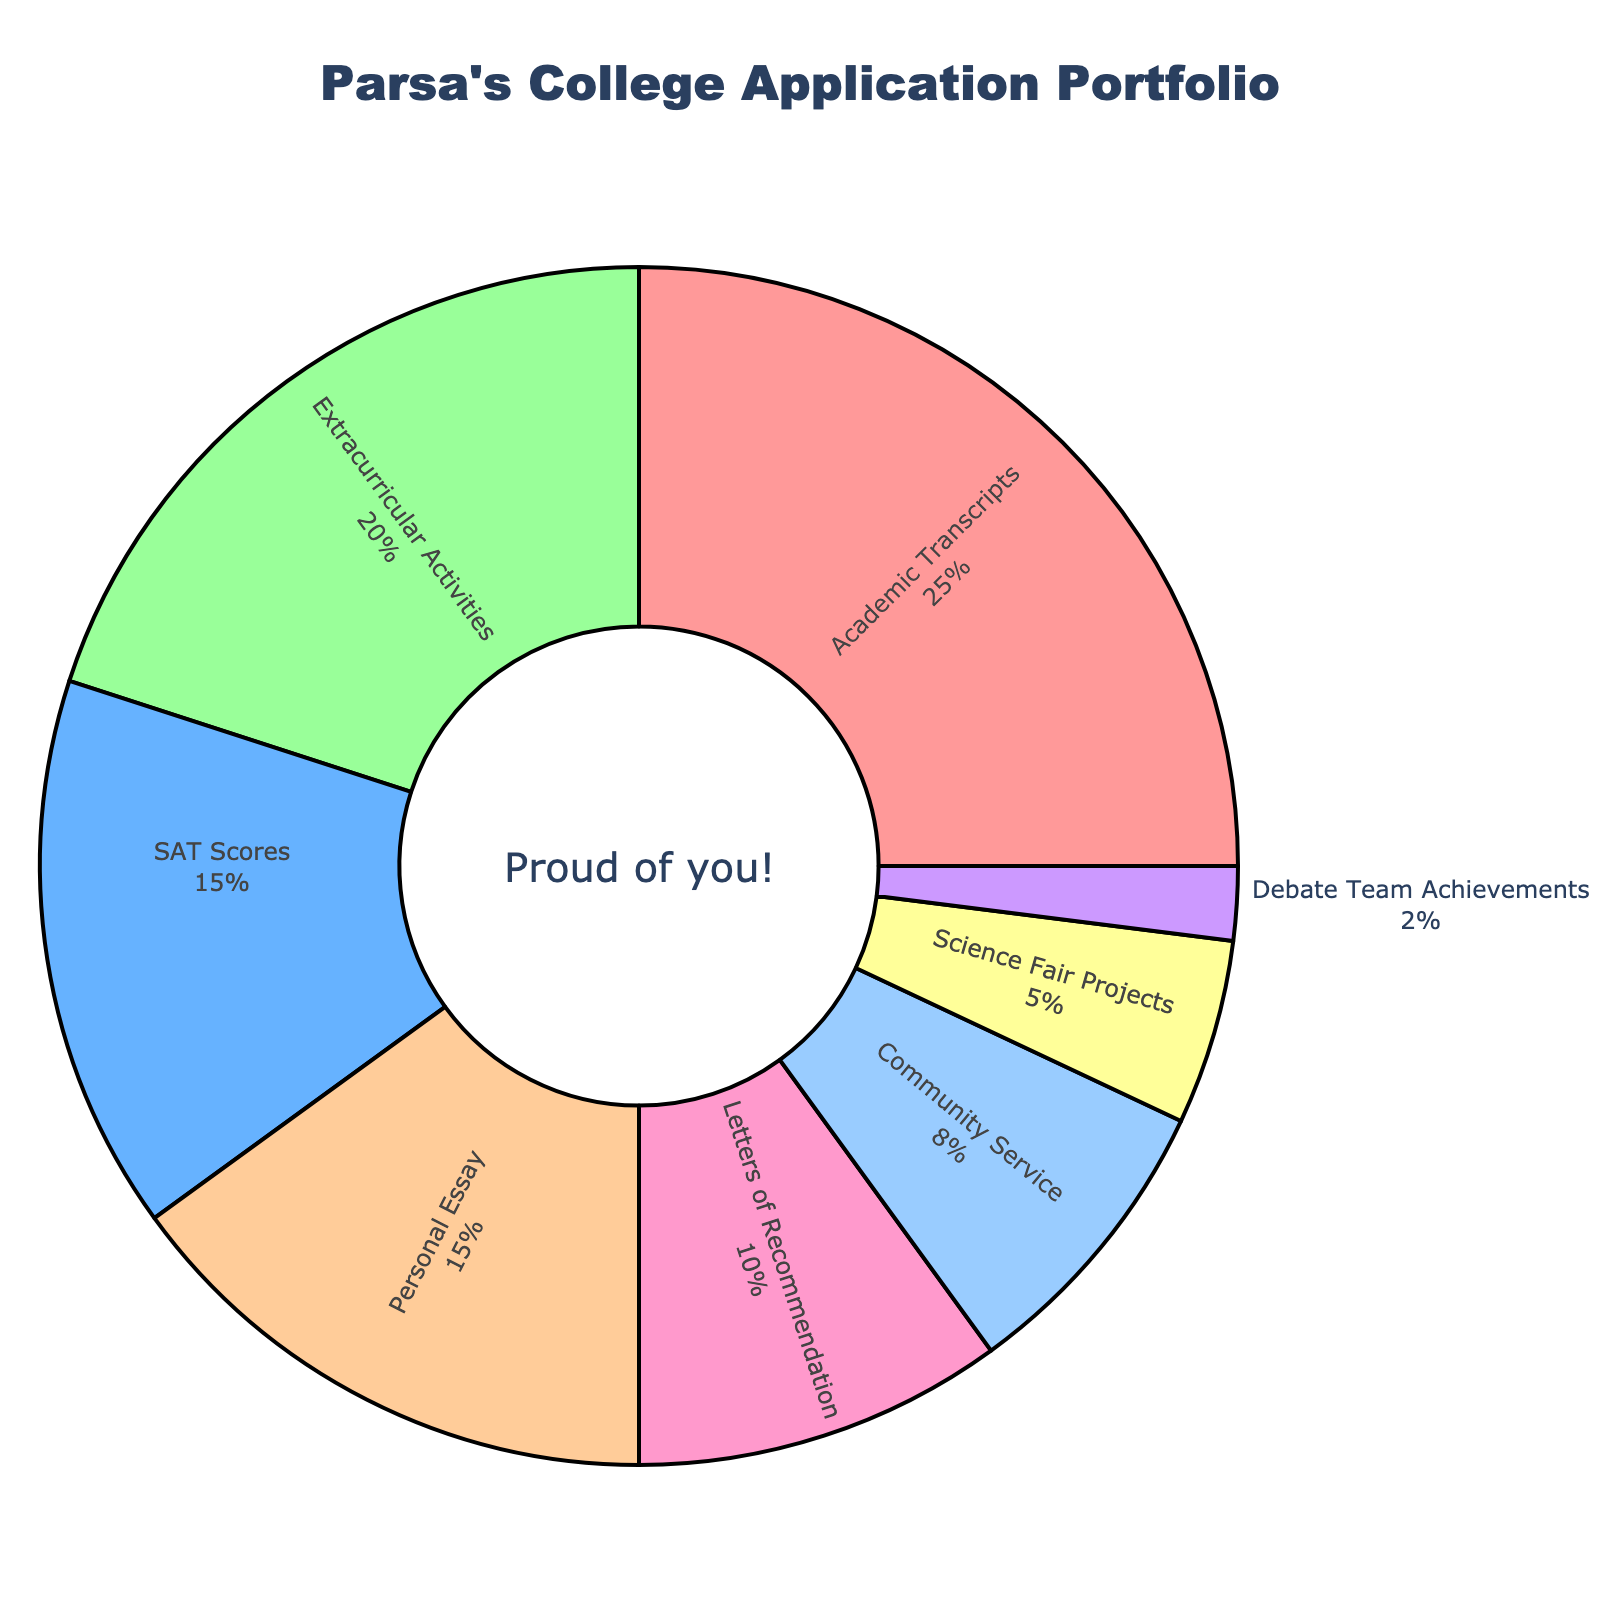What's the largest component of Parsa's college application portfolio? The largest component can be identified by looking for the segment with the biggest percentage. The "Academic Transcripts" segment is the largest with 25%.
Answer: Academic Transcripts What is the combined percentage of "Personal Essay" and "SAT Scores"? The percentages for "Personal Essay" and "SAT Scores" are 15% each. Adding these together gives 15 + 15 = 30%.
Answer: 30% Which component has the smallest percentage, and what is that percentage? The smallest segment has to be the one with the smallest value. The "Debate Team Achievements" is the smallest with 2%.
Answer: Debate Team Achievements, 2% By how much does the "Extracurricular Activities" percentage exceed the "Community Service" percentage? Subtract the "Community Service" percentage (8%) from the "Extracurricular Activities" percentage (20%) to find the difference: 20 - 8 = 12%.
Answer: 12% What components collectively make up more than 50% of the application portfolio? By summing the largest components until the total exceeds 50%, we find that "Academic Transcripts" (25%), "Extracurricular Activities" (20%), and "SAT Scores" (15%) together total 60%, which is more than 50%.
Answer: Academic Transcripts, Extracurricular Activities, SAT Scores What is the percentage difference between the "Letters of Recommendation" and "Science Fair Projects" components? Subtract the percentage of "Science Fair Projects" (5%) from "Letters of Recommendation" (10%): 10 - 5 = 5%.
Answer: 5% If the "Extracurricular Activities" and "Community Service" percentages were combined into one component, what would be the new percentage? Adding the "Extracurricular Activities" (20%) and "Community Service" (8%) together results in: 20 + 8 = 28%.
Answer: 28% Which component has a higher percentage, "Personal Essay" or "Science Fair Projects," and by how much? Subtract the percentage of "Science Fair Projects" (5%) from the "Personal Essay" (15%): 15 - 5 = 10%.
Answer: Personal Essay, 10% In percentage terms, how much more significant are the "Academic Transcripts" than the "Debate Team Achievements"? Subtract the percentage of "Debate Team Achievements" (2%) from "Academic Transcripts" (25%): 25 - 2 = 23%.
Answer: 23% What is the total percentage contribution of components related to academic achievements (Academic Transcripts, SAT Scores, Science Fair Projects)? Summing up the percentages of "Academic Transcripts" (25%), "SAT Scores" (15%), and "Science Fair Projects" (5%): 25 + 15 + 5 = 45%.
Answer: 45% 